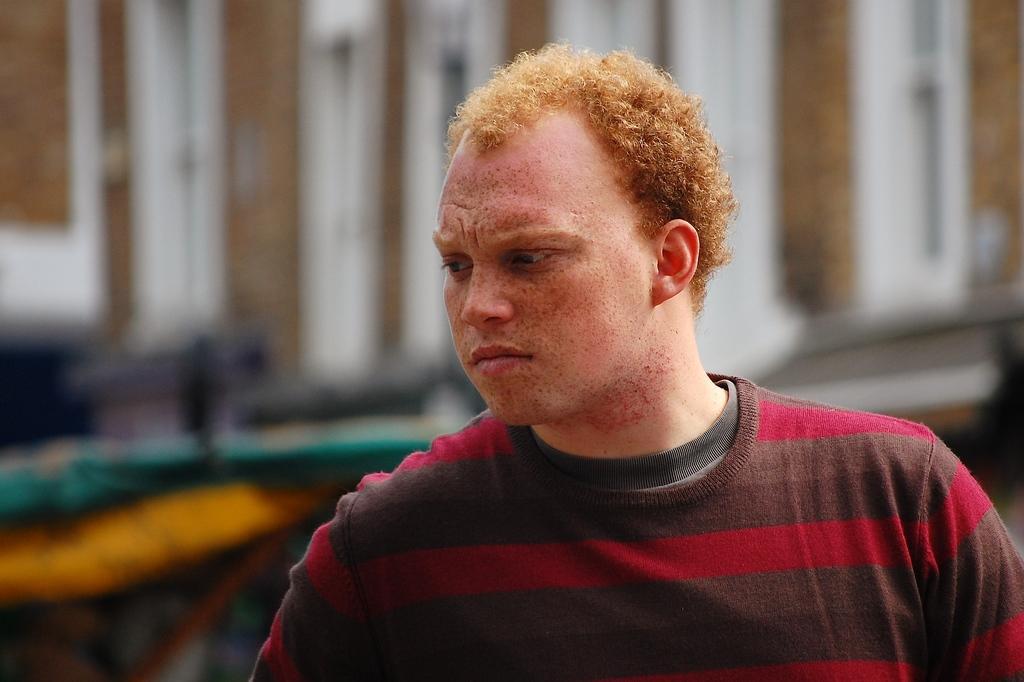In one or two sentences, can you explain what this image depicts? In this picture we can see a man and blurry background. 